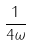Convert formula to latex. <formula><loc_0><loc_0><loc_500><loc_500>\frac { 1 } { 4 \omega }</formula> 